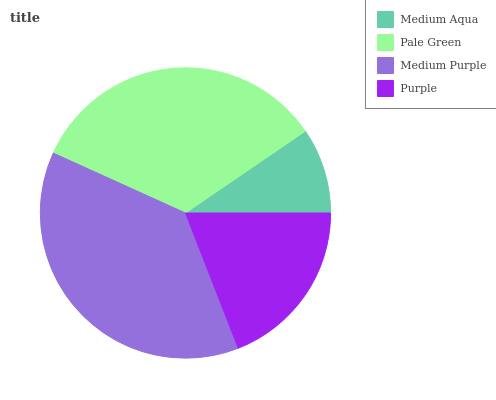Is Medium Aqua the minimum?
Answer yes or no. Yes. Is Medium Purple the maximum?
Answer yes or no. Yes. Is Pale Green the minimum?
Answer yes or no. No. Is Pale Green the maximum?
Answer yes or no. No. Is Pale Green greater than Medium Aqua?
Answer yes or no. Yes. Is Medium Aqua less than Pale Green?
Answer yes or no. Yes. Is Medium Aqua greater than Pale Green?
Answer yes or no. No. Is Pale Green less than Medium Aqua?
Answer yes or no. No. Is Pale Green the high median?
Answer yes or no. Yes. Is Purple the low median?
Answer yes or no. Yes. Is Medium Purple the high median?
Answer yes or no. No. Is Medium Aqua the low median?
Answer yes or no. No. 